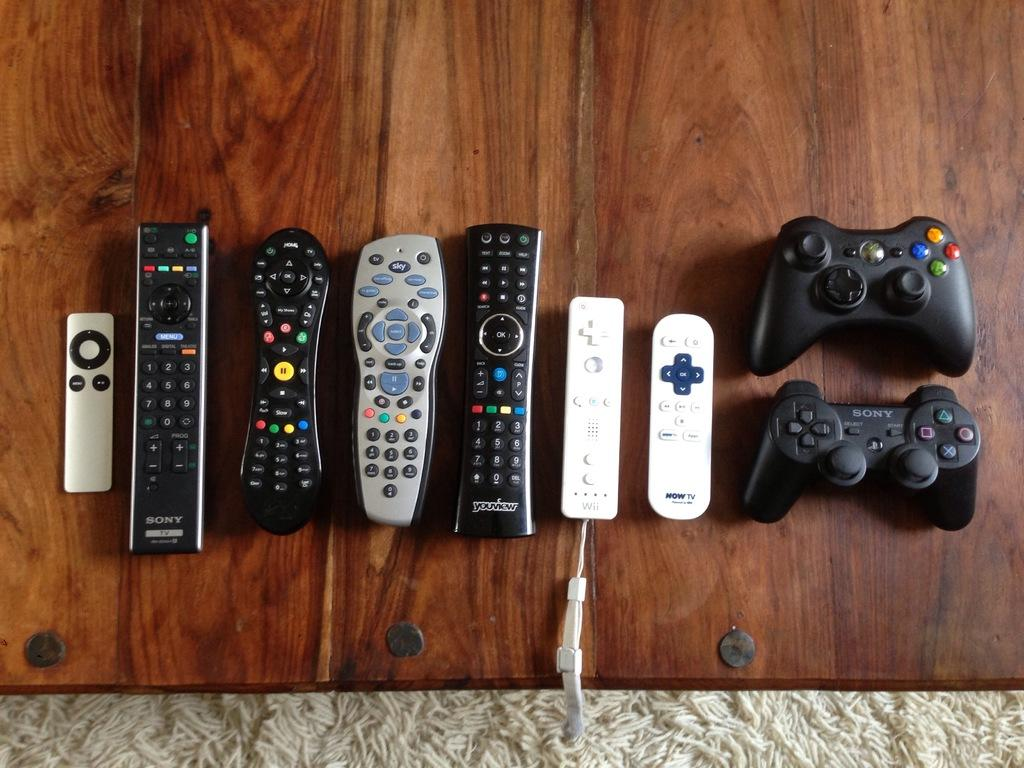<image>
Render a clear and concise summary of the photo. A bunch of remove control on the table, and two of them say Sony. 